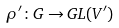Convert formula to latex. <formula><loc_0><loc_0><loc_500><loc_500>\rho ^ { \prime } \colon G \to { G L } ( V ^ { \prime } )</formula> 